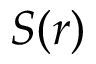Convert formula to latex. <formula><loc_0><loc_0><loc_500><loc_500>S ( r )</formula> 